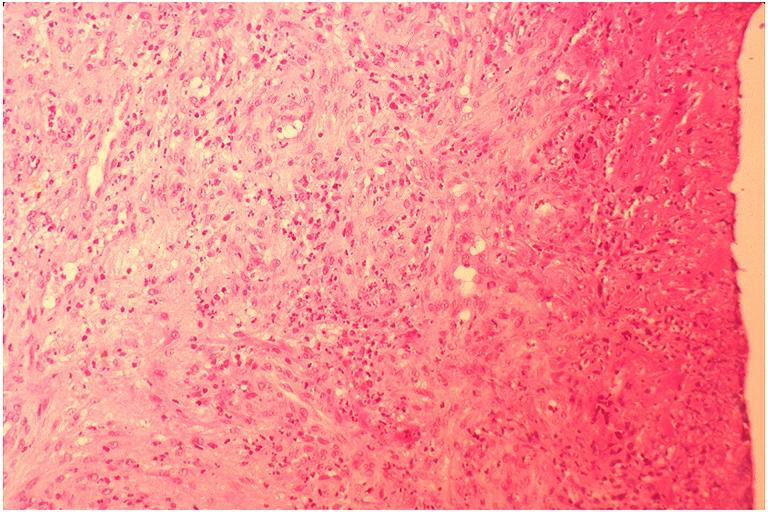s squamous cell carcinoma, lip remote, present?
Answer the question using a single word or phrase. No 